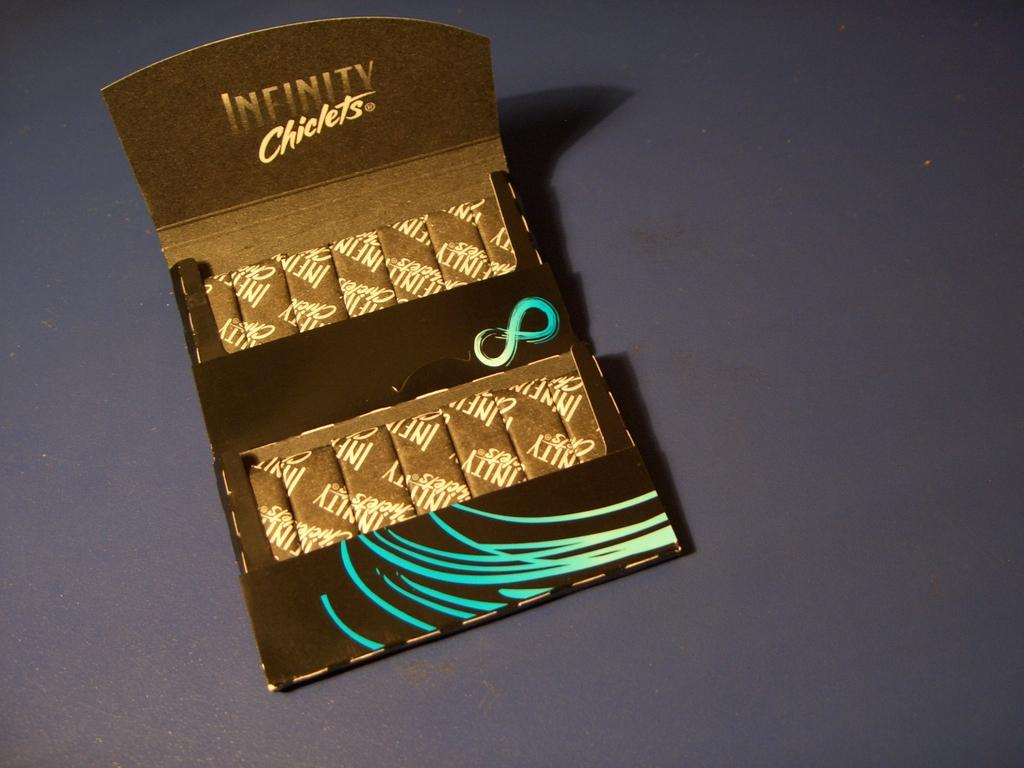<image>
Render a clear and concise summary of the photo. an open box of gum for Infinity chiclets 